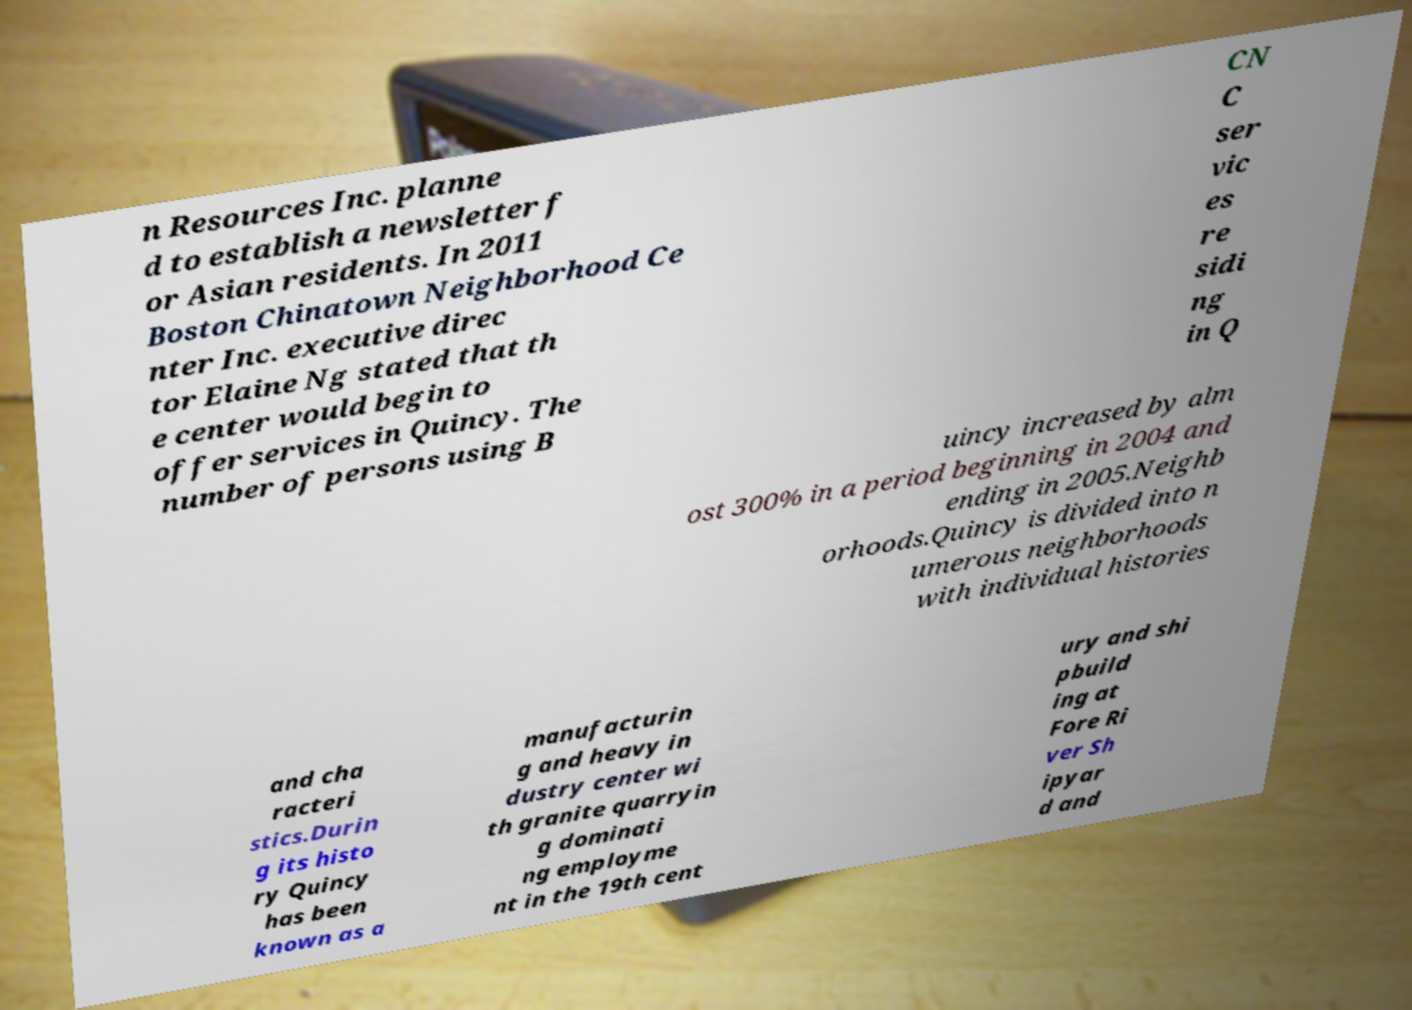For documentation purposes, I need the text within this image transcribed. Could you provide that? n Resources Inc. planne d to establish a newsletter f or Asian residents. In 2011 Boston Chinatown Neighborhood Ce nter Inc. executive direc tor Elaine Ng stated that th e center would begin to offer services in Quincy. The number of persons using B CN C ser vic es re sidi ng in Q uincy increased by alm ost 300% in a period beginning in 2004 and ending in 2005.Neighb orhoods.Quincy is divided into n umerous neighborhoods with individual histories and cha racteri stics.Durin g its histo ry Quincy has been known as a manufacturin g and heavy in dustry center wi th granite quarryin g dominati ng employme nt in the 19th cent ury and shi pbuild ing at Fore Ri ver Sh ipyar d and 